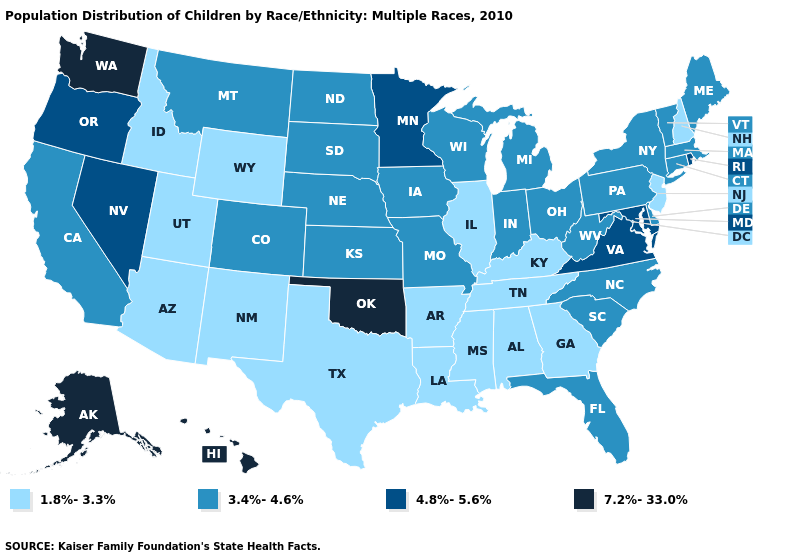What is the value of Wyoming?
Answer briefly. 1.8%-3.3%. Name the states that have a value in the range 7.2%-33.0%?
Write a very short answer. Alaska, Hawaii, Oklahoma, Washington. Among the states that border North Carolina , which have the highest value?
Short answer required. Virginia. Name the states that have a value in the range 3.4%-4.6%?
Concise answer only. California, Colorado, Connecticut, Delaware, Florida, Indiana, Iowa, Kansas, Maine, Massachusetts, Michigan, Missouri, Montana, Nebraska, New York, North Carolina, North Dakota, Ohio, Pennsylvania, South Carolina, South Dakota, Vermont, West Virginia, Wisconsin. Name the states that have a value in the range 3.4%-4.6%?
Answer briefly. California, Colorado, Connecticut, Delaware, Florida, Indiana, Iowa, Kansas, Maine, Massachusetts, Michigan, Missouri, Montana, Nebraska, New York, North Carolina, North Dakota, Ohio, Pennsylvania, South Carolina, South Dakota, Vermont, West Virginia, Wisconsin. Among the states that border Oklahoma , which have the lowest value?
Concise answer only. Arkansas, New Mexico, Texas. Among the states that border South Carolina , which have the lowest value?
Write a very short answer. Georgia. Name the states that have a value in the range 4.8%-5.6%?
Keep it brief. Maryland, Minnesota, Nevada, Oregon, Rhode Island, Virginia. Among the states that border Colorado , does Oklahoma have the highest value?
Keep it brief. Yes. Name the states that have a value in the range 1.8%-3.3%?
Keep it brief. Alabama, Arizona, Arkansas, Georgia, Idaho, Illinois, Kentucky, Louisiana, Mississippi, New Hampshire, New Jersey, New Mexico, Tennessee, Texas, Utah, Wyoming. Which states have the lowest value in the USA?
Keep it brief. Alabama, Arizona, Arkansas, Georgia, Idaho, Illinois, Kentucky, Louisiana, Mississippi, New Hampshire, New Jersey, New Mexico, Tennessee, Texas, Utah, Wyoming. Name the states that have a value in the range 4.8%-5.6%?
Short answer required. Maryland, Minnesota, Nevada, Oregon, Rhode Island, Virginia. What is the value of Nebraska?
Keep it brief. 3.4%-4.6%. What is the value of Maine?
Concise answer only. 3.4%-4.6%. What is the value of Florida?
Give a very brief answer. 3.4%-4.6%. 